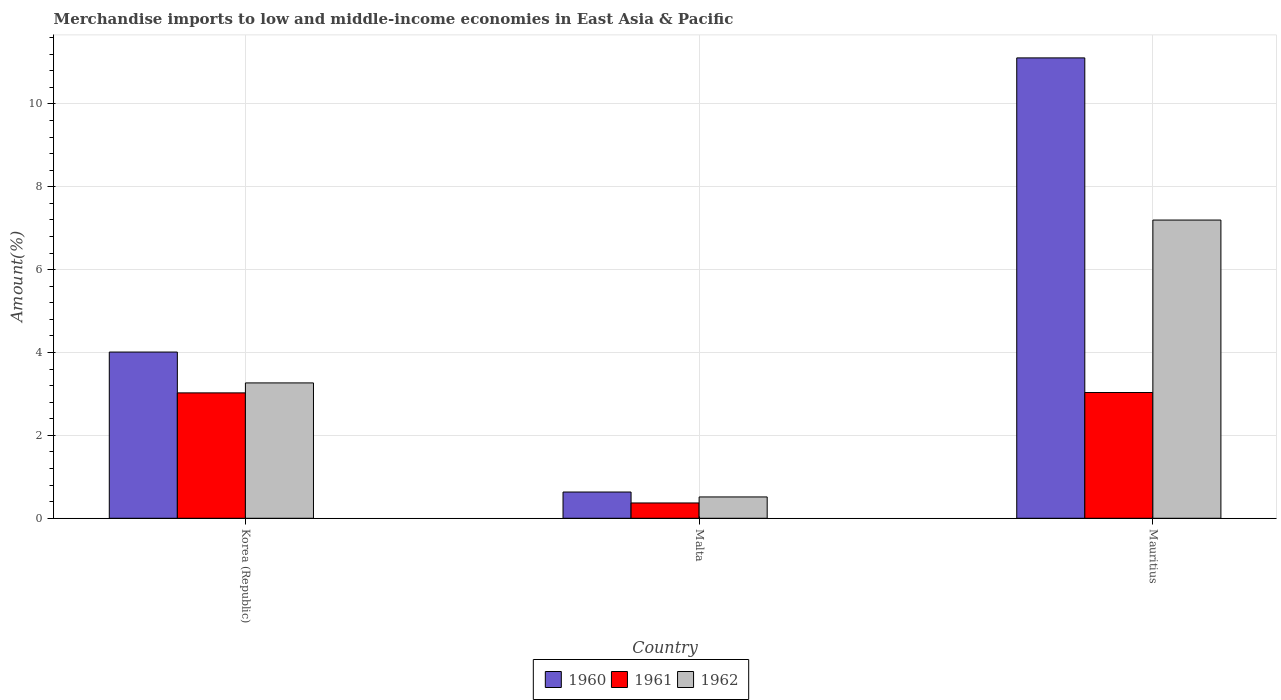Are the number of bars per tick equal to the number of legend labels?
Your answer should be very brief. Yes. Are the number of bars on each tick of the X-axis equal?
Keep it short and to the point. Yes. How many bars are there on the 2nd tick from the left?
Make the answer very short. 3. What is the label of the 3rd group of bars from the left?
Ensure brevity in your answer.  Mauritius. What is the percentage of amount earned from merchandise imports in 1961 in Malta?
Offer a terse response. 0.37. Across all countries, what is the maximum percentage of amount earned from merchandise imports in 1961?
Provide a succinct answer. 3.03. Across all countries, what is the minimum percentage of amount earned from merchandise imports in 1961?
Your answer should be very brief. 0.37. In which country was the percentage of amount earned from merchandise imports in 1960 maximum?
Offer a very short reply. Mauritius. In which country was the percentage of amount earned from merchandise imports in 1960 minimum?
Keep it short and to the point. Malta. What is the total percentage of amount earned from merchandise imports in 1962 in the graph?
Offer a very short reply. 10.98. What is the difference between the percentage of amount earned from merchandise imports in 1960 in Korea (Republic) and that in Mauritius?
Provide a short and direct response. -7.1. What is the difference between the percentage of amount earned from merchandise imports in 1962 in Mauritius and the percentage of amount earned from merchandise imports in 1961 in Korea (Republic)?
Make the answer very short. 4.17. What is the average percentage of amount earned from merchandise imports in 1962 per country?
Provide a succinct answer. 3.66. What is the difference between the percentage of amount earned from merchandise imports of/in 1961 and percentage of amount earned from merchandise imports of/in 1960 in Mauritius?
Your answer should be very brief. -8.08. In how many countries, is the percentage of amount earned from merchandise imports in 1961 greater than 4.8 %?
Ensure brevity in your answer.  0. What is the ratio of the percentage of amount earned from merchandise imports in 1962 in Malta to that in Mauritius?
Your response must be concise. 0.07. Is the percentage of amount earned from merchandise imports in 1962 in Korea (Republic) less than that in Malta?
Your response must be concise. No. What is the difference between the highest and the second highest percentage of amount earned from merchandise imports in 1962?
Your response must be concise. -2.75. What is the difference between the highest and the lowest percentage of amount earned from merchandise imports in 1961?
Offer a very short reply. 2.67. What does the 2nd bar from the right in Korea (Republic) represents?
Provide a succinct answer. 1961. How many countries are there in the graph?
Your answer should be compact. 3. What is the difference between two consecutive major ticks on the Y-axis?
Provide a succinct answer. 2. Does the graph contain any zero values?
Your answer should be very brief. No. Does the graph contain grids?
Provide a short and direct response. Yes. How many legend labels are there?
Offer a terse response. 3. How are the legend labels stacked?
Your response must be concise. Horizontal. What is the title of the graph?
Give a very brief answer. Merchandise imports to low and middle-income economies in East Asia & Pacific. What is the label or title of the X-axis?
Offer a very short reply. Country. What is the label or title of the Y-axis?
Provide a short and direct response. Amount(%). What is the Amount(%) of 1960 in Korea (Republic)?
Provide a short and direct response. 4.01. What is the Amount(%) in 1961 in Korea (Republic)?
Keep it short and to the point. 3.03. What is the Amount(%) in 1962 in Korea (Republic)?
Provide a succinct answer. 3.27. What is the Amount(%) of 1960 in Malta?
Ensure brevity in your answer.  0.63. What is the Amount(%) in 1961 in Malta?
Your answer should be very brief. 0.37. What is the Amount(%) of 1962 in Malta?
Your response must be concise. 0.51. What is the Amount(%) in 1960 in Mauritius?
Make the answer very short. 11.11. What is the Amount(%) in 1961 in Mauritius?
Offer a terse response. 3.03. What is the Amount(%) of 1962 in Mauritius?
Offer a terse response. 7.2. Across all countries, what is the maximum Amount(%) in 1960?
Your response must be concise. 11.11. Across all countries, what is the maximum Amount(%) in 1961?
Offer a terse response. 3.03. Across all countries, what is the maximum Amount(%) of 1962?
Your response must be concise. 7.2. Across all countries, what is the minimum Amount(%) in 1960?
Keep it short and to the point. 0.63. Across all countries, what is the minimum Amount(%) in 1961?
Offer a very short reply. 0.37. Across all countries, what is the minimum Amount(%) in 1962?
Your answer should be compact. 0.51. What is the total Amount(%) of 1960 in the graph?
Ensure brevity in your answer.  15.76. What is the total Amount(%) of 1961 in the graph?
Keep it short and to the point. 6.43. What is the total Amount(%) of 1962 in the graph?
Keep it short and to the point. 10.98. What is the difference between the Amount(%) of 1960 in Korea (Republic) and that in Malta?
Your response must be concise. 3.38. What is the difference between the Amount(%) of 1961 in Korea (Republic) and that in Malta?
Your answer should be very brief. 2.66. What is the difference between the Amount(%) of 1962 in Korea (Republic) and that in Malta?
Offer a terse response. 2.75. What is the difference between the Amount(%) of 1960 in Korea (Republic) and that in Mauritius?
Provide a short and direct response. -7.1. What is the difference between the Amount(%) of 1961 in Korea (Republic) and that in Mauritius?
Give a very brief answer. -0.01. What is the difference between the Amount(%) of 1962 in Korea (Republic) and that in Mauritius?
Offer a very short reply. -3.93. What is the difference between the Amount(%) of 1960 in Malta and that in Mauritius?
Your response must be concise. -10.48. What is the difference between the Amount(%) of 1961 in Malta and that in Mauritius?
Your response must be concise. -2.67. What is the difference between the Amount(%) in 1962 in Malta and that in Mauritius?
Your answer should be compact. -6.68. What is the difference between the Amount(%) in 1960 in Korea (Republic) and the Amount(%) in 1961 in Malta?
Provide a short and direct response. 3.64. What is the difference between the Amount(%) of 1960 in Korea (Republic) and the Amount(%) of 1962 in Malta?
Provide a short and direct response. 3.5. What is the difference between the Amount(%) in 1961 in Korea (Republic) and the Amount(%) in 1962 in Malta?
Your answer should be very brief. 2.51. What is the difference between the Amount(%) in 1960 in Korea (Republic) and the Amount(%) in 1961 in Mauritius?
Make the answer very short. 0.98. What is the difference between the Amount(%) in 1960 in Korea (Republic) and the Amount(%) in 1962 in Mauritius?
Keep it short and to the point. -3.19. What is the difference between the Amount(%) of 1961 in Korea (Republic) and the Amount(%) of 1962 in Mauritius?
Ensure brevity in your answer.  -4.17. What is the difference between the Amount(%) of 1960 in Malta and the Amount(%) of 1961 in Mauritius?
Offer a very short reply. -2.4. What is the difference between the Amount(%) in 1960 in Malta and the Amount(%) in 1962 in Mauritius?
Offer a very short reply. -6.56. What is the difference between the Amount(%) of 1961 in Malta and the Amount(%) of 1962 in Mauritius?
Offer a very short reply. -6.83. What is the average Amount(%) in 1960 per country?
Your response must be concise. 5.25. What is the average Amount(%) of 1961 per country?
Your answer should be very brief. 2.14. What is the average Amount(%) of 1962 per country?
Ensure brevity in your answer.  3.66. What is the difference between the Amount(%) in 1960 and Amount(%) in 1961 in Korea (Republic)?
Provide a succinct answer. 0.99. What is the difference between the Amount(%) of 1960 and Amount(%) of 1962 in Korea (Republic)?
Your answer should be very brief. 0.74. What is the difference between the Amount(%) of 1961 and Amount(%) of 1962 in Korea (Republic)?
Your answer should be very brief. -0.24. What is the difference between the Amount(%) of 1960 and Amount(%) of 1961 in Malta?
Keep it short and to the point. 0.26. What is the difference between the Amount(%) in 1960 and Amount(%) in 1962 in Malta?
Ensure brevity in your answer.  0.12. What is the difference between the Amount(%) of 1961 and Amount(%) of 1962 in Malta?
Give a very brief answer. -0.15. What is the difference between the Amount(%) of 1960 and Amount(%) of 1961 in Mauritius?
Provide a succinct answer. 8.08. What is the difference between the Amount(%) in 1960 and Amount(%) in 1962 in Mauritius?
Offer a very short reply. 3.91. What is the difference between the Amount(%) of 1961 and Amount(%) of 1962 in Mauritius?
Your answer should be compact. -4.16. What is the ratio of the Amount(%) of 1960 in Korea (Republic) to that in Malta?
Give a very brief answer. 6.33. What is the ratio of the Amount(%) of 1961 in Korea (Republic) to that in Malta?
Offer a very short reply. 8.19. What is the ratio of the Amount(%) in 1962 in Korea (Republic) to that in Malta?
Provide a succinct answer. 6.35. What is the ratio of the Amount(%) of 1960 in Korea (Republic) to that in Mauritius?
Your answer should be compact. 0.36. What is the ratio of the Amount(%) in 1961 in Korea (Republic) to that in Mauritius?
Ensure brevity in your answer.  1. What is the ratio of the Amount(%) in 1962 in Korea (Republic) to that in Mauritius?
Offer a terse response. 0.45. What is the ratio of the Amount(%) in 1960 in Malta to that in Mauritius?
Your response must be concise. 0.06. What is the ratio of the Amount(%) in 1961 in Malta to that in Mauritius?
Keep it short and to the point. 0.12. What is the ratio of the Amount(%) of 1962 in Malta to that in Mauritius?
Provide a succinct answer. 0.07. What is the difference between the highest and the second highest Amount(%) in 1960?
Offer a terse response. 7.1. What is the difference between the highest and the second highest Amount(%) in 1961?
Your answer should be very brief. 0.01. What is the difference between the highest and the second highest Amount(%) of 1962?
Provide a succinct answer. 3.93. What is the difference between the highest and the lowest Amount(%) of 1960?
Ensure brevity in your answer.  10.48. What is the difference between the highest and the lowest Amount(%) in 1961?
Offer a very short reply. 2.67. What is the difference between the highest and the lowest Amount(%) of 1962?
Your answer should be compact. 6.68. 